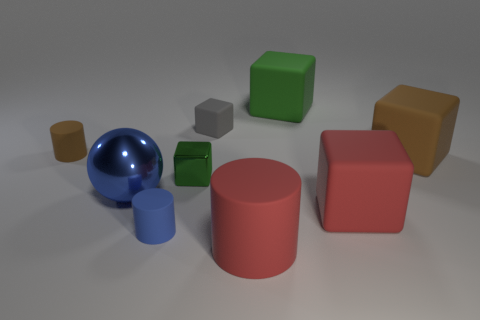The other tiny cylinder that is made of the same material as the brown cylinder is what color?
Make the answer very short. Blue. How many green metal things have the same size as the shiny cube?
Offer a terse response. 0. How many other things are there of the same color as the big rubber cylinder?
Offer a very short reply. 1. There is a big red matte object that is in front of the red block; is it the same shape as the brown object to the left of the large red matte cylinder?
Provide a succinct answer. Yes. What shape is the blue thing that is the same size as the red rubber cube?
Your answer should be very brief. Sphere. Are there the same number of tiny matte cylinders that are in front of the big blue sphere and red rubber cubes that are on the right side of the large matte cylinder?
Provide a succinct answer. Yes. Are there any other things that are the same shape as the big blue shiny thing?
Provide a succinct answer. No. Is the green object in front of the brown matte cylinder made of the same material as the big blue object?
Ensure brevity in your answer.  Yes. There is a brown cube that is the same size as the metal ball; what is it made of?
Provide a succinct answer. Rubber. How many other things are there of the same material as the gray object?
Ensure brevity in your answer.  6. 